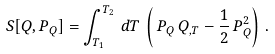<formula> <loc_0><loc_0><loc_500><loc_500>S [ Q , P _ { Q } ] = \int _ { T _ { 1 } } ^ { T _ { 2 } } \, d T \, \left ( \, P _ { Q } \, Q _ { , T } - \frac { 1 } { 2 } \, { P } _ { Q } ^ { 2 } \right ) \, .</formula> 